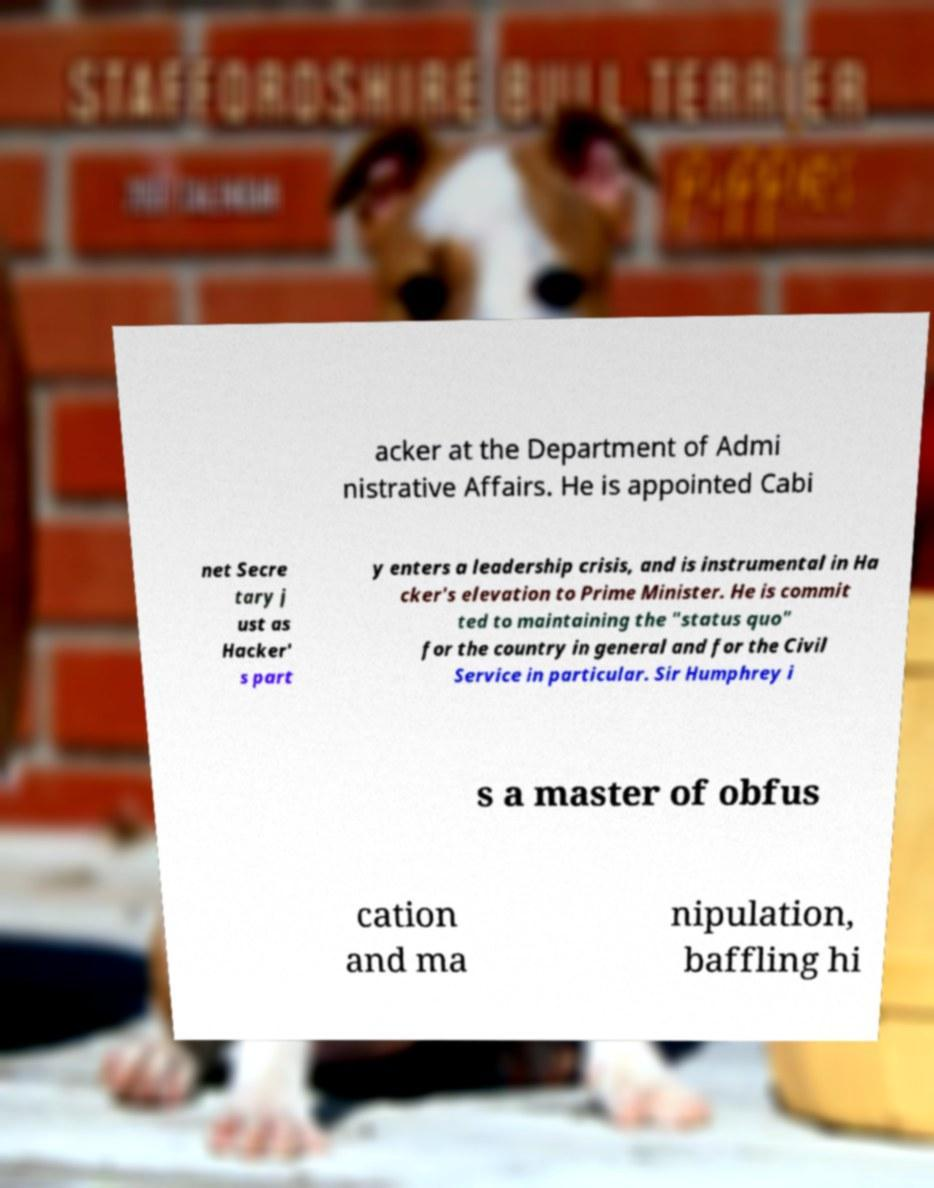Can you accurately transcribe the text from the provided image for me? acker at the Department of Admi nistrative Affairs. He is appointed Cabi net Secre tary j ust as Hacker' s part y enters a leadership crisis, and is instrumental in Ha cker's elevation to Prime Minister. He is commit ted to maintaining the "status quo" for the country in general and for the Civil Service in particular. Sir Humphrey i s a master of obfus cation and ma nipulation, baffling hi 